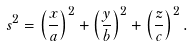Convert formula to latex. <formula><loc_0><loc_0><loc_500><loc_500>s ^ { 2 } = \left ( \frac { x } { a } \right ) ^ { 2 } + \left ( \frac { y } { b } \right ) ^ { 2 } + \left ( \frac { z } { c } \right ) ^ { 2 } .</formula> 